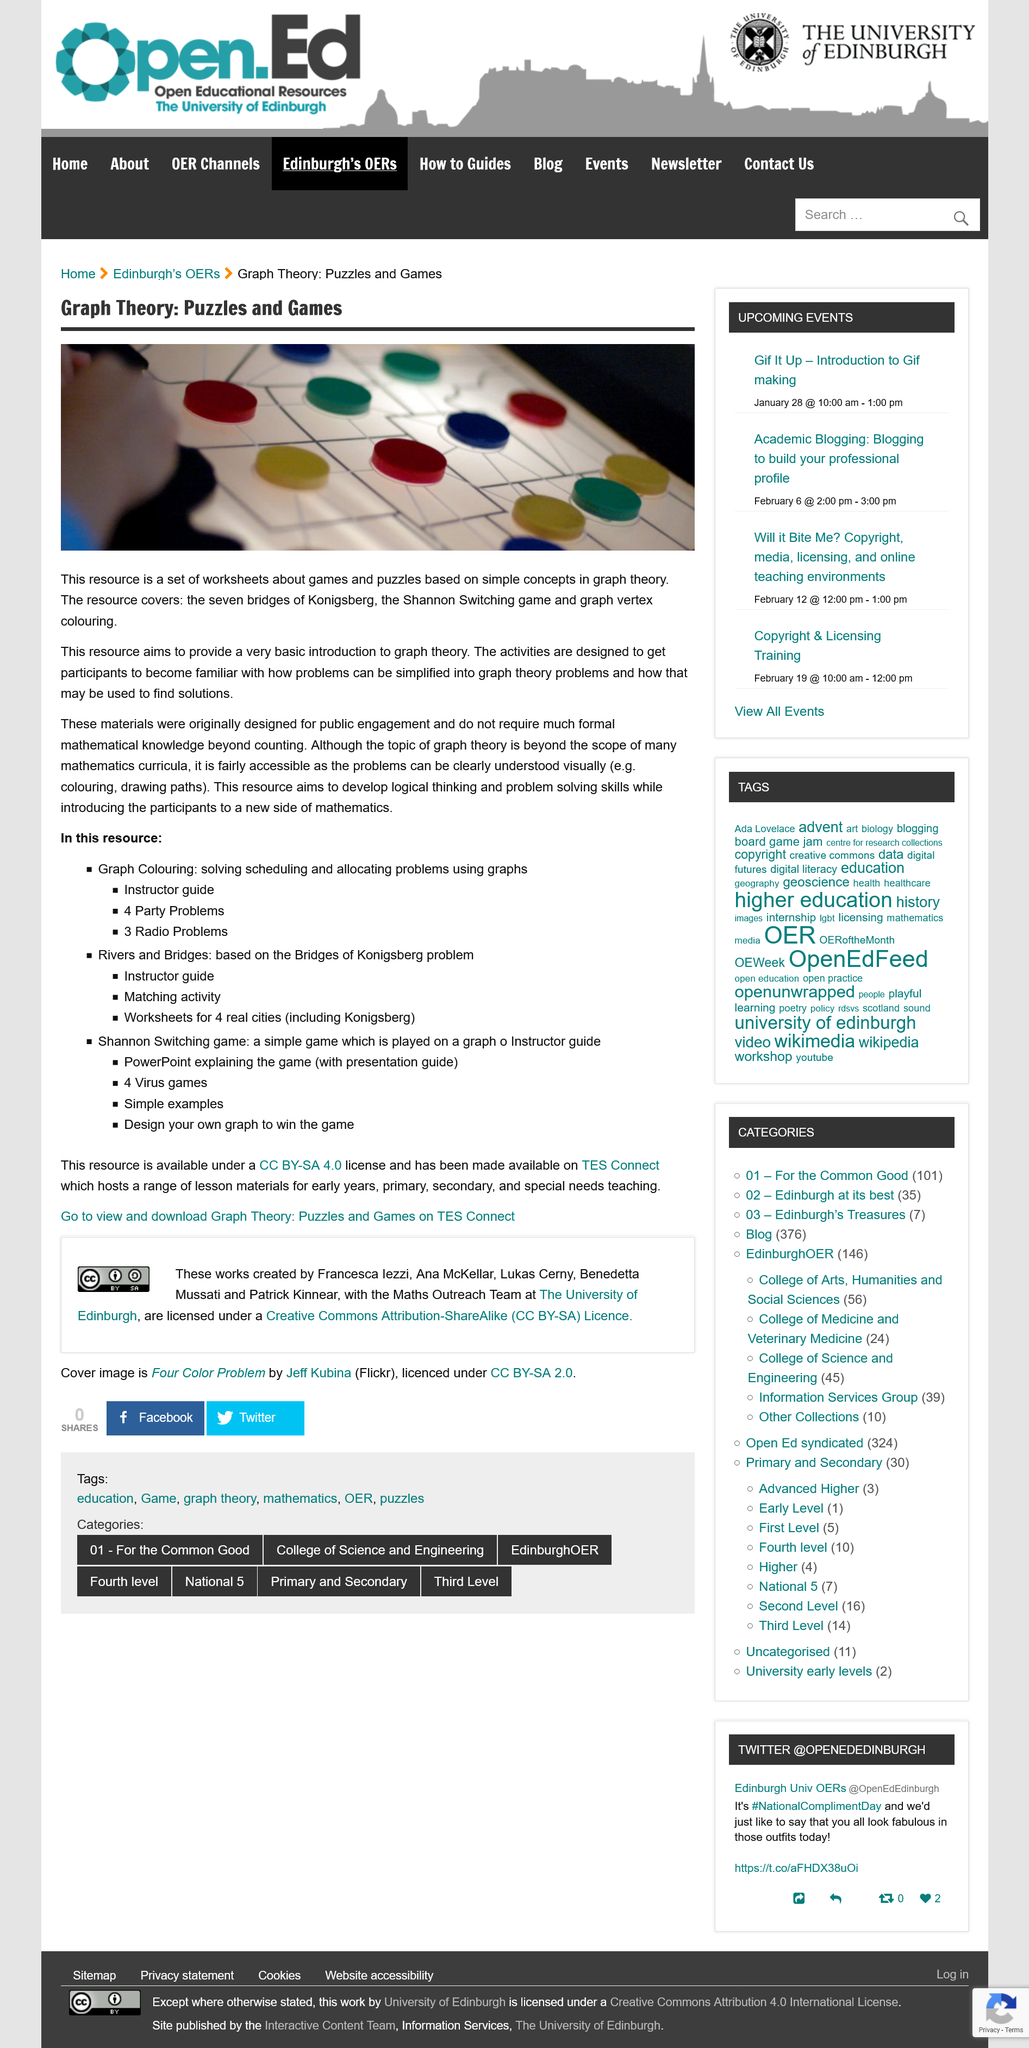Specify some key components in this picture. This resource falls under three main categories: graph colouring, rivers and bridges, and Shannon Switching game. This resource hosts a range of lesson materials for early years, primary, secondary, and special needs teaching. Graph colouring and the Shannon switching game are methods for solving, scheduling, and allocating resources in various contexts, such as in graphs and in the context of a game played on a graph. An instructor guide may be used to teach about these methods. The resource provides information on the seven bridges of Konigsberg, the Shannon Switching game, and graph vertex coloring. The resources aim to provide a basic introduction to graph theory, and their original purpose was for public engagement. 